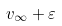Convert formula to latex. <formula><loc_0><loc_0><loc_500><loc_500>v _ { \infty } + \varepsilon</formula> 